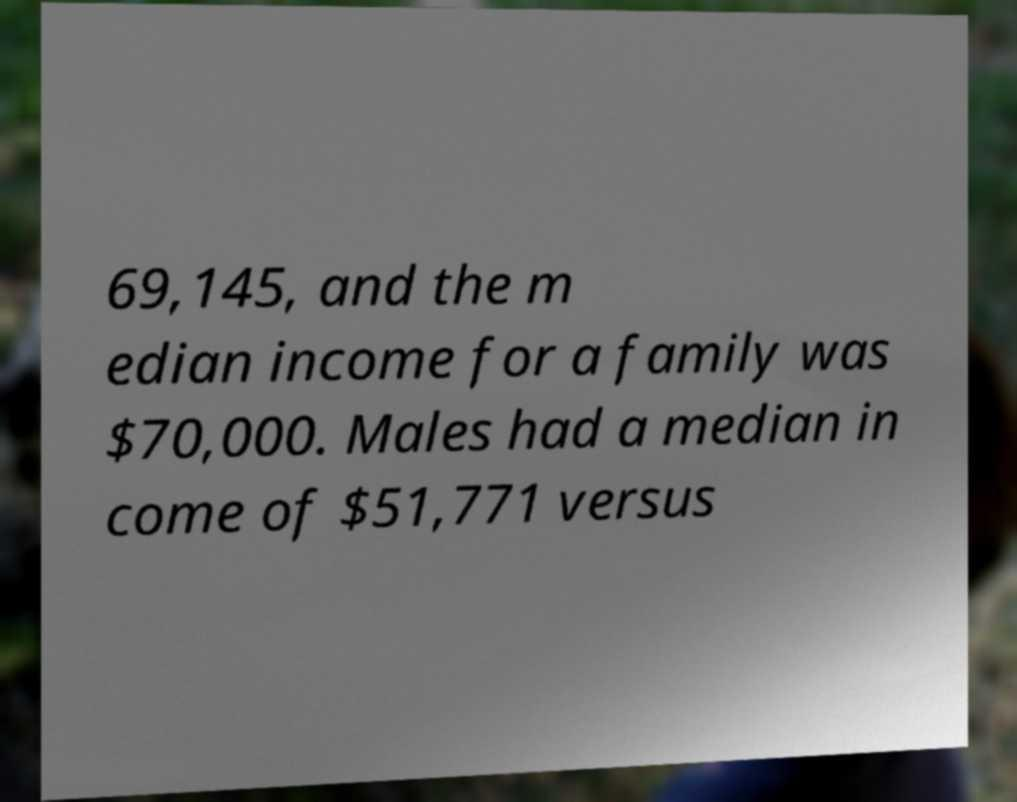There's text embedded in this image that I need extracted. Can you transcribe it verbatim? 69,145, and the m edian income for a family was $70,000. Males had a median in come of $51,771 versus 